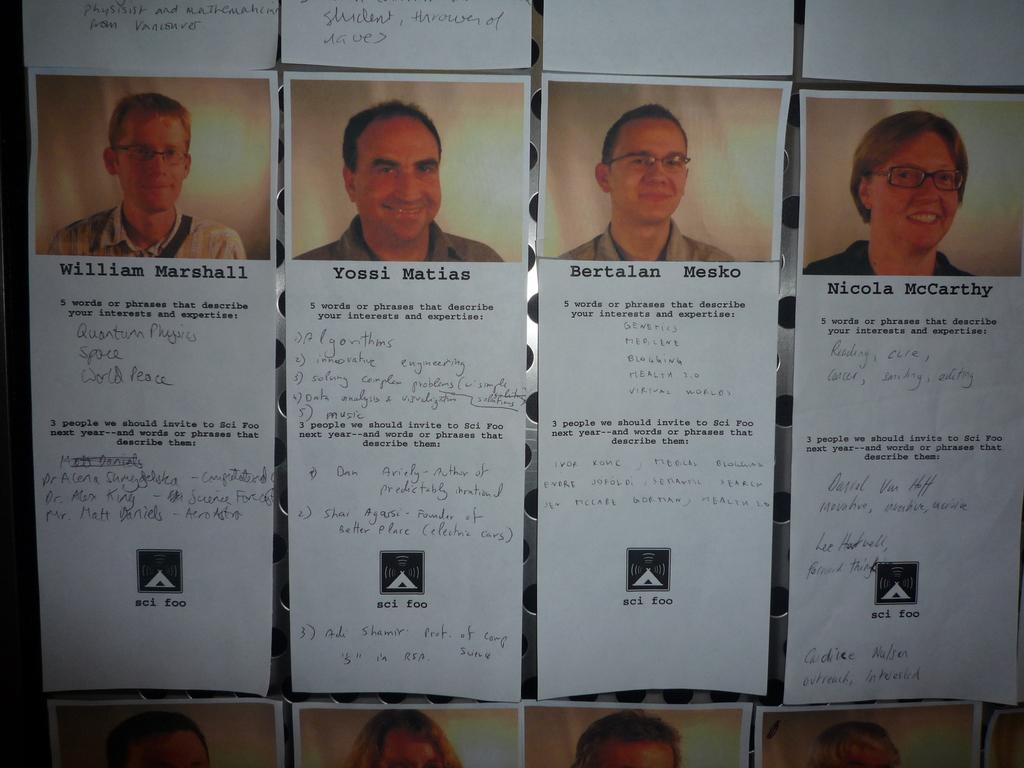What can be seen on the papers in the image? There are persons depicted on the papers, and there is text on the papers. Can you describe the type of text on the papers? Unfortunately, the specific content of the text cannot be determined from the image. What is visible in the background of the image? There is a metal object in the background of the image. How many baskets are visible in the image? There are no baskets present in the image. What type of work are the persons on the papers engaged in? The specific activities or occupations of the persons depicted on the papers cannot be determined from the image. 